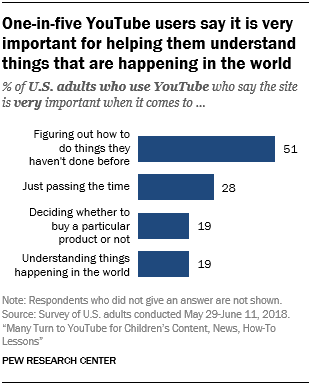Mention a couple of crucial points in this snapshot. The largest bar has a value of 51. Of the bars that have values equal to 19, approximately 2 of them have values equal to 19. 